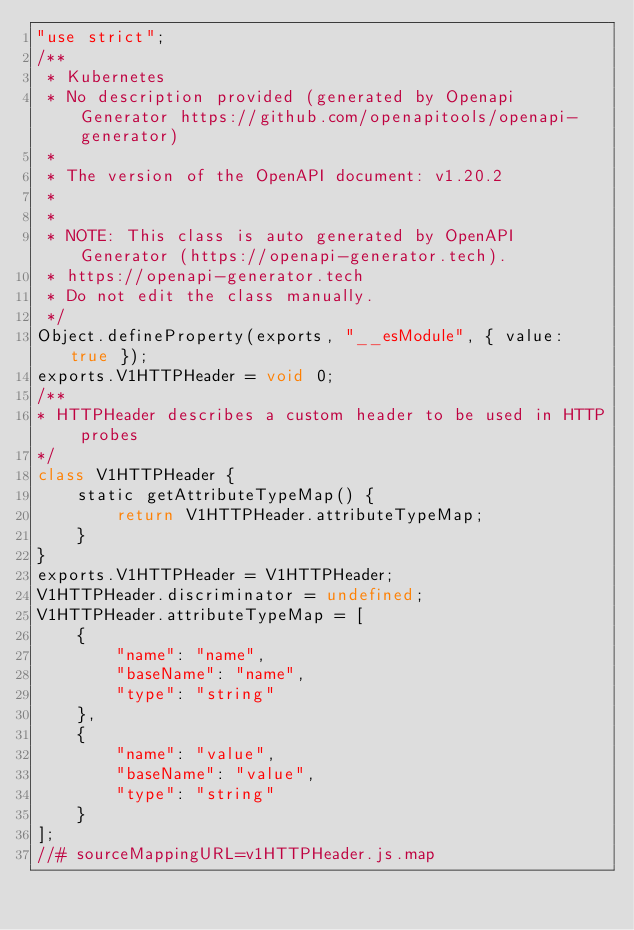Convert code to text. <code><loc_0><loc_0><loc_500><loc_500><_JavaScript_>"use strict";
/**
 * Kubernetes
 * No description provided (generated by Openapi Generator https://github.com/openapitools/openapi-generator)
 *
 * The version of the OpenAPI document: v1.20.2
 *
 *
 * NOTE: This class is auto generated by OpenAPI Generator (https://openapi-generator.tech).
 * https://openapi-generator.tech
 * Do not edit the class manually.
 */
Object.defineProperty(exports, "__esModule", { value: true });
exports.V1HTTPHeader = void 0;
/**
* HTTPHeader describes a custom header to be used in HTTP probes
*/
class V1HTTPHeader {
    static getAttributeTypeMap() {
        return V1HTTPHeader.attributeTypeMap;
    }
}
exports.V1HTTPHeader = V1HTTPHeader;
V1HTTPHeader.discriminator = undefined;
V1HTTPHeader.attributeTypeMap = [
    {
        "name": "name",
        "baseName": "name",
        "type": "string"
    },
    {
        "name": "value",
        "baseName": "value",
        "type": "string"
    }
];
//# sourceMappingURL=v1HTTPHeader.js.map</code> 